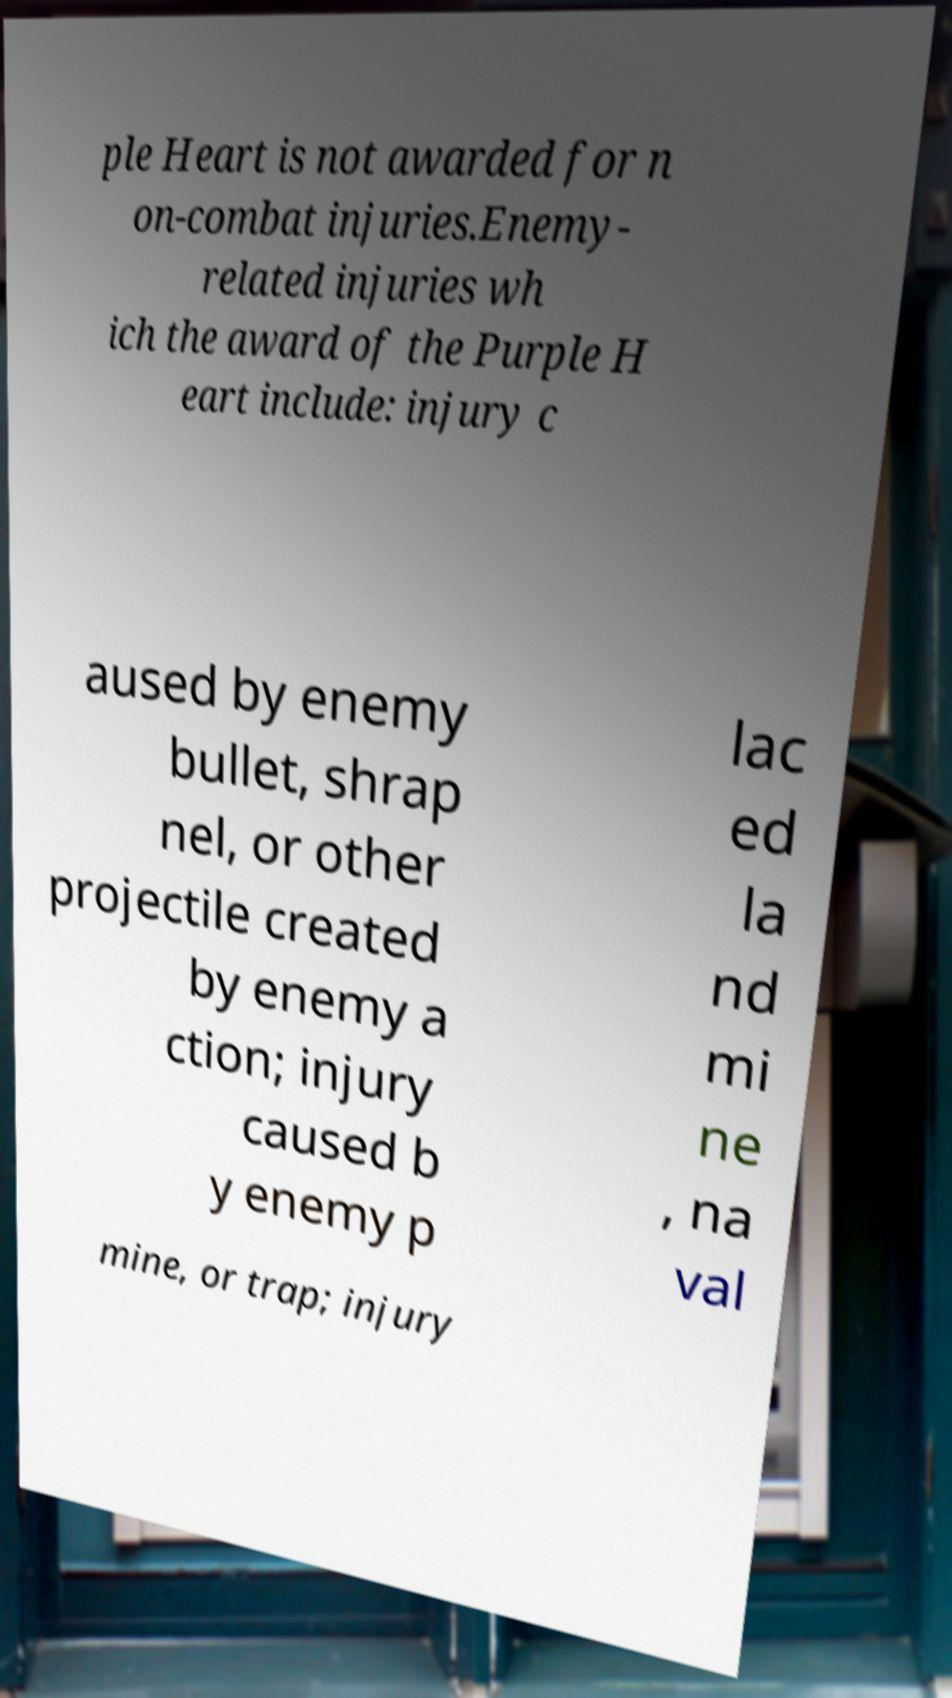For documentation purposes, I need the text within this image transcribed. Could you provide that? ple Heart is not awarded for n on-combat injuries.Enemy- related injuries wh ich the award of the Purple H eart include: injury c aused by enemy bullet, shrap nel, or other projectile created by enemy a ction; injury caused b y enemy p lac ed la nd mi ne , na val mine, or trap; injury 